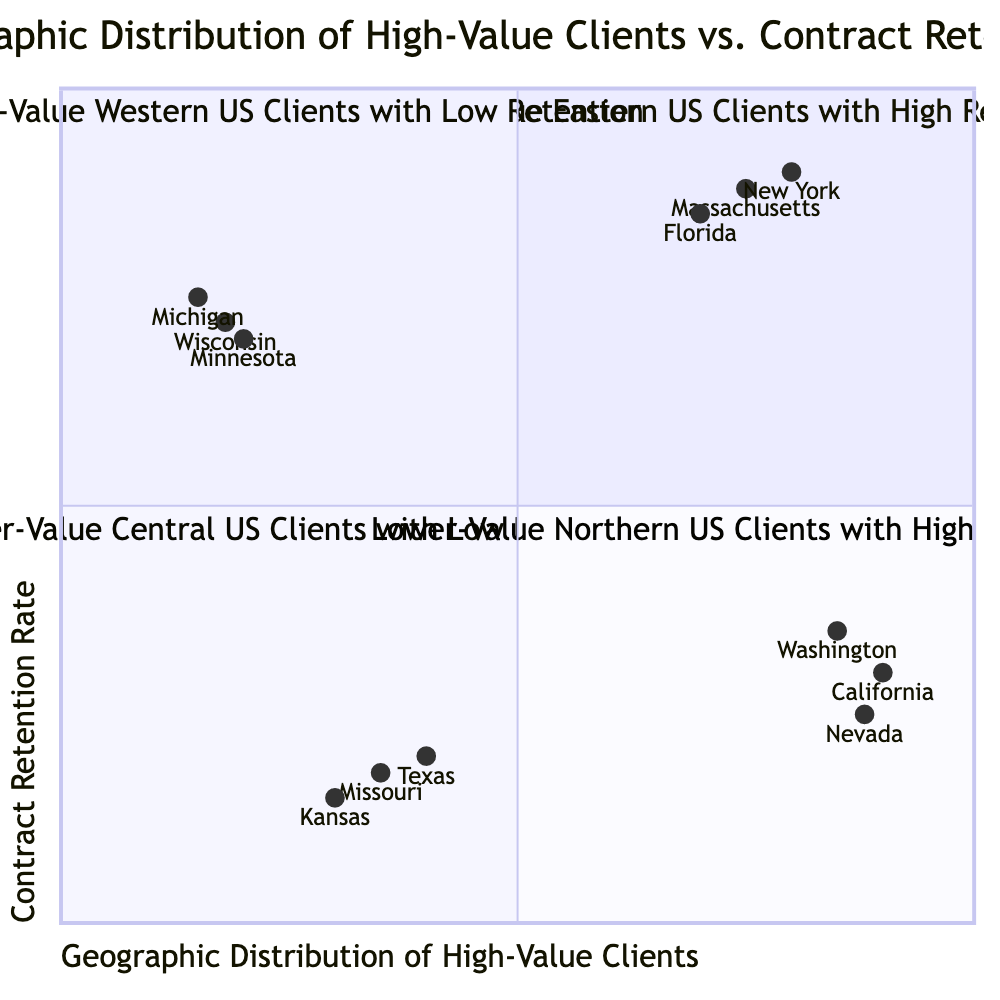What is the focus area for Q1? Q1 represents High-Value Eastern US Clients with High Retention, highlighting clients in the Eastern US who have a strong tendency to renew contracts.
Answer: High-Value Eastern US Clients with High Retention Which quadrant has clients in California? California is identified in Q2, which features High-Value Western US Clients with Low Retention, indicating this region has high-value clients but struggles with contract renewals.
Answer: Q2 How many examples are listed for Q4? The examples listed for Q4 show three states: Minnesota, Michigan, and Wisconsin, which indicates that there are three examples provided for this quadrant.
Answer: Three What is the contract retention rate for clients in Texas? Texas clients fall under Q3, with a contract retention rate of 0.2, reflecting poor retention among lower-value clients in this region.
Answer: 0.2 Which quadrant represents Lower-Value clients with High Retention? Q4 illustrates the focus on Lower-Value Northern US Clients with High Retention, denoting that this quadrant includes lower-value clients but they maintain a good contract retention rate.
Answer: Q4 What is the overall description of Q2? Q2 describes High-Value Western US Clients with Low Retention, meaning these clients hold high value but lack loyalty as evidenced by their low contract retention rates.
Answer: High-Value Western US Clients with Low Retention What geographical area is focused on in Q3? Q3 is centered on Lower-Value Central US Clients with Low Retention, indicating that this area primarily includes clients from the Central region of the US with a tendency for low retention.
Answer: Central US How does the contract retention rate for Florida compare to Massachusetts? Florida has a contract retention rate of 0.85, while Massachusetts has a higher retention rate of 0.88, indicating that Massachusetts clients are slightly more loyal compared to those from Florida.
Answer: Massachusetts has higher retention What type of clients does Q1 focus on? Q1 emphasizes on high-value clients located in the Eastern US with high contract retention rates, showcasing a strong focus area for retaining premium clients in this geographic location.
Answer: High-value clients in Eastern US 